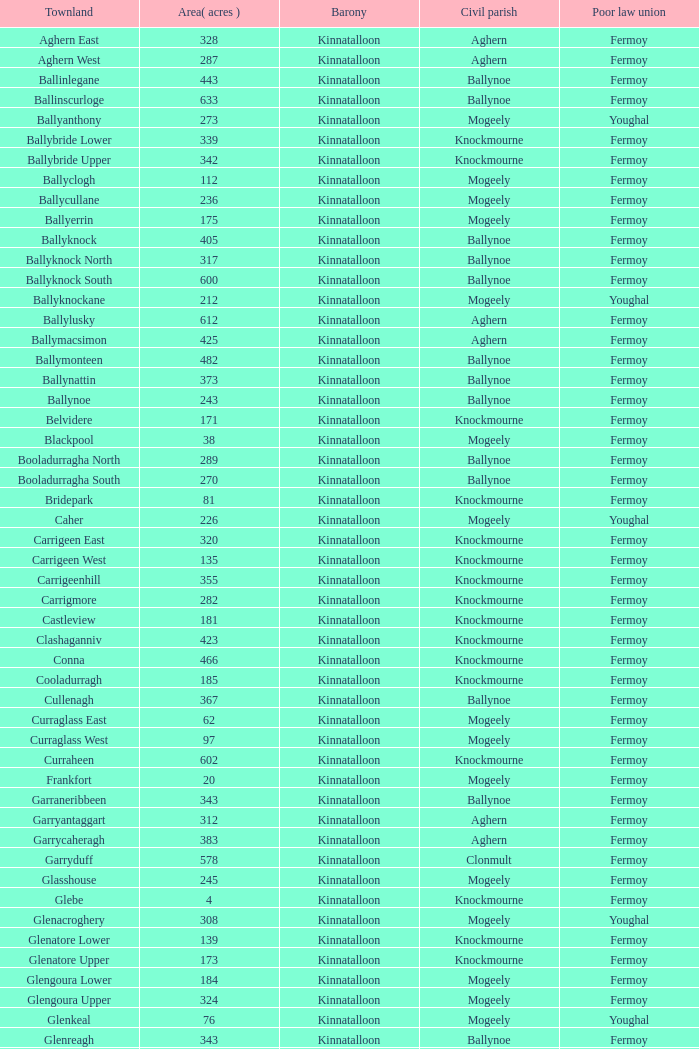What is the townland called for both fermoy and ballynoe? Ballinlegane, Ballinscurloge, Ballyknock, Ballyknock North, Ballyknock South, Ballymonteen, Ballynattin, Ballynoe, Booladurragha North, Booladurragha South, Cullenagh, Garraneribbeen, Glenreagh, Glentane, Killasseragh, Kilphillibeen, Knockakeo, Longueville North, Longueville South, Rathdrum, Shanaboola. 